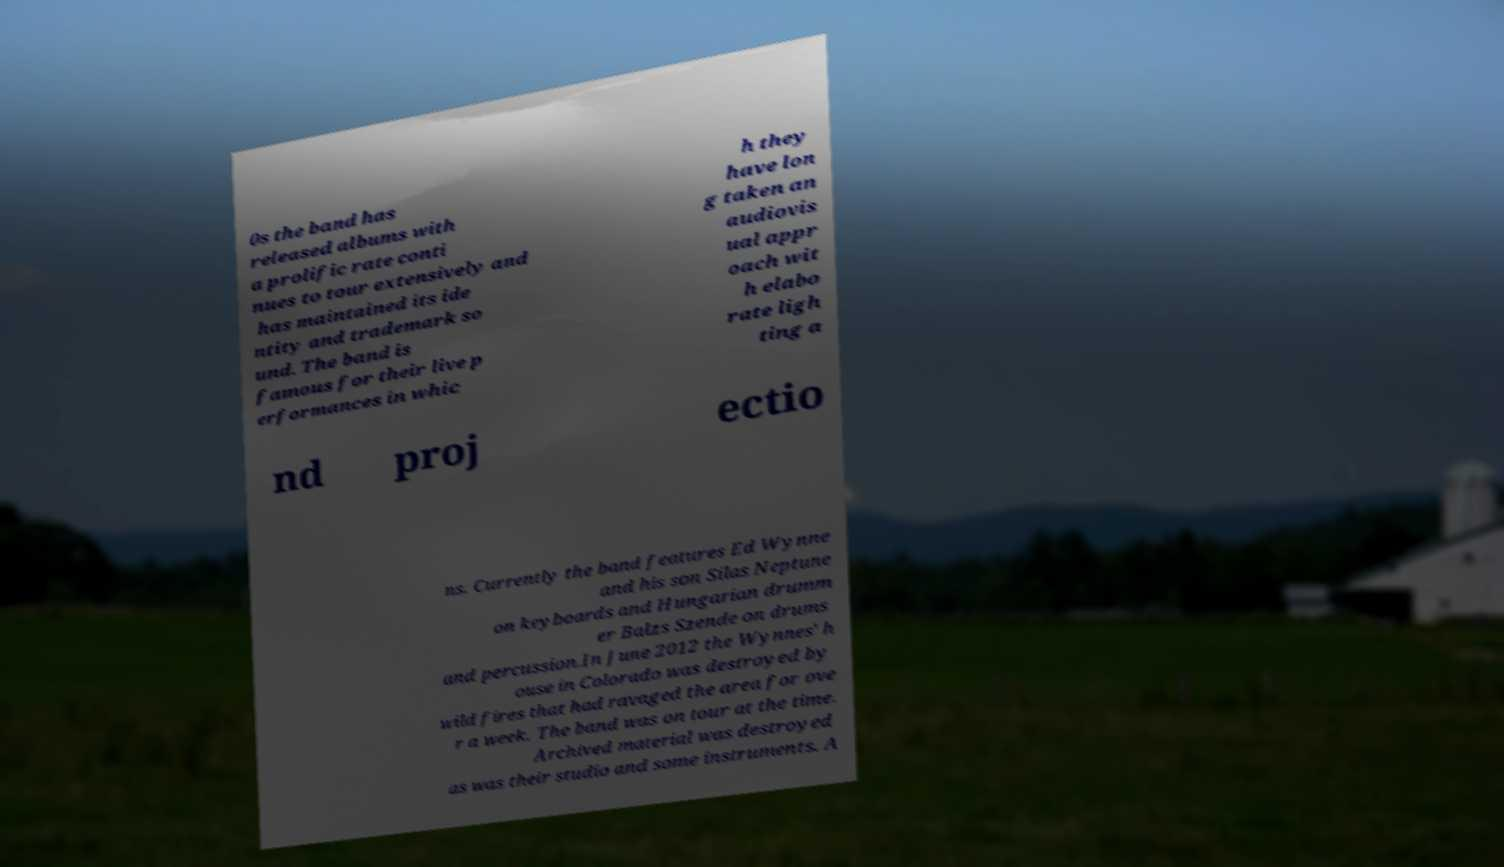Could you assist in decoding the text presented in this image and type it out clearly? 0s the band has released albums with a prolific rate conti nues to tour extensively and has maintained its ide ntity and trademark so und. The band is famous for their live p erformances in whic h they have lon g taken an audiovis ual appr oach wit h elabo rate ligh ting a nd proj ectio ns. Currently the band features Ed Wynne and his son Silas Neptune on keyboards and Hungarian drumm er Balzs Szende on drums and percussion.In June 2012 the Wynnes' h ouse in Colorado was destroyed by wild fires that had ravaged the area for ove r a week. The band was on tour at the time. Archived material was destroyed as was their studio and some instruments. A 